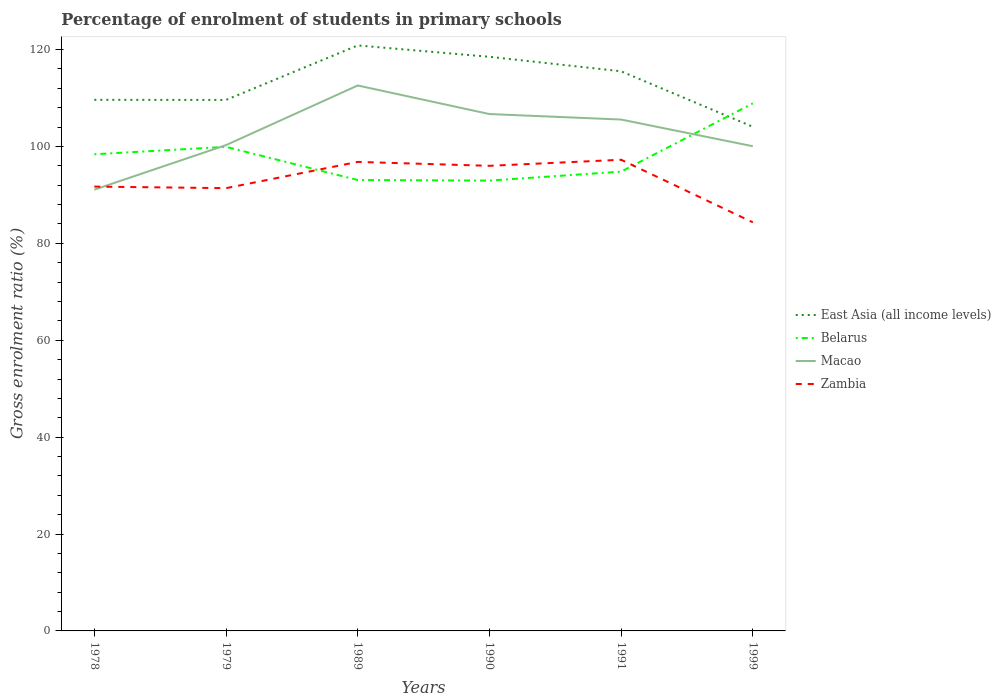Across all years, what is the maximum percentage of students enrolled in primary schools in East Asia (all income levels)?
Your response must be concise. 104.06. What is the total percentage of students enrolled in primary schools in Macao in the graph?
Your answer should be compact. -6.41. What is the difference between the highest and the second highest percentage of students enrolled in primary schools in Macao?
Ensure brevity in your answer.  21.51. How many lines are there?
Provide a succinct answer. 4. How many years are there in the graph?
Make the answer very short. 6. What is the difference between two consecutive major ticks on the Y-axis?
Your response must be concise. 20. Are the values on the major ticks of Y-axis written in scientific E-notation?
Keep it short and to the point. No. Where does the legend appear in the graph?
Give a very brief answer. Center right. How are the legend labels stacked?
Your answer should be compact. Vertical. What is the title of the graph?
Give a very brief answer. Percentage of enrolment of students in primary schools. Does "Pacific island small states" appear as one of the legend labels in the graph?
Your response must be concise. No. What is the label or title of the Y-axis?
Provide a short and direct response. Gross enrolment ratio (%). What is the Gross enrolment ratio (%) of East Asia (all income levels) in 1978?
Offer a very short reply. 109.63. What is the Gross enrolment ratio (%) in Belarus in 1978?
Your response must be concise. 98.39. What is the Gross enrolment ratio (%) in Macao in 1978?
Make the answer very short. 91.08. What is the Gross enrolment ratio (%) of Zambia in 1978?
Keep it short and to the point. 91.71. What is the Gross enrolment ratio (%) in East Asia (all income levels) in 1979?
Make the answer very short. 109.6. What is the Gross enrolment ratio (%) in Belarus in 1979?
Offer a very short reply. 99.92. What is the Gross enrolment ratio (%) of Macao in 1979?
Ensure brevity in your answer.  100.28. What is the Gross enrolment ratio (%) of Zambia in 1979?
Offer a terse response. 91.39. What is the Gross enrolment ratio (%) of East Asia (all income levels) in 1989?
Give a very brief answer. 120.86. What is the Gross enrolment ratio (%) of Belarus in 1989?
Give a very brief answer. 93.07. What is the Gross enrolment ratio (%) in Macao in 1989?
Make the answer very short. 112.59. What is the Gross enrolment ratio (%) of Zambia in 1989?
Provide a succinct answer. 96.81. What is the Gross enrolment ratio (%) of East Asia (all income levels) in 1990?
Your response must be concise. 118.51. What is the Gross enrolment ratio (%) in Belarus in 1990?
Make the answer very short. 92.96. What is the Gross enrolment ratio (%) in Macao in 1990?
Offer a very short reply. 106.69. What is the Gross enrolment ratio (%) of Zambia in 1990?
Give a very brief answer. 96. What is the Gross enrolment ratio (%) of East Asia (all income levels) in 1991?
Your answer should be compact. 115.52. What is the Gross enrolment ratio (%) in Belarus in 1991?
Your response must be concise. 94.8. What is the Gross enrolment ratio (%) of Macao in 1991?
Your answer should be very brief. 105.55. What is the Gross enrolment ratio (%) in Zambia in 1991?
Provide a short and direct response. 97.25. What is the Gross enrolment ratio (%) in East Asia (all income levels) in 1999?
Keep it short and to the point. 104.06. What is the Gross enrolment ratio (%) of Belarus in 1999?
Ensure brevity in your answer.  108.89. What is the Gross enrolment ratio (%) in Macao in 1999?
Provide a short and direct response. 100.05. What is the Gross enrolment ratio (%) in Zambia in 1999?
Your answer should be very brief. 84.34. Across all years, what is the maximum Gross enrolment ratio (%) of East Asia (all income levels)?
Your answer should be very brief. 120.86. Across all years, what is the maximum Gross enrolment ratio (%) in Belarus?
Provide a short and direct response. 108.89. Across all years, what is the maximum Gross enrolment ratio (%) of Macao?
Provide a short and direct response. 112.59. Across all years, what is the maximum Gross enrolment ratio (%) in Zambia?
Provide a short and direct response. 97.25. Across all years, what is the minimum Gross enrolment ratio (%) of East Asia (all income levels)?
Provide a short and direct response. 104.06. Across all years, what is the minimum Gross enrolment ratio (%) of Belarus?
Give a very brief answer. 92.96. Across all years, what is the minimum Gross enrolment ratio (%) in Macao?
Ensure brevity in your answer.  91.08. Across all years, what is the minimum Gross enrolment ratio (%) of Zambia?
Provide a short and direct response. 84.34. What is the total Gross enrolment ratio (%) in East Asia (all income levels) in the graph?
Offer a terse response. 678.17. What is the total Gross enrolment ratio (%) of Belarus in the graph?
Make the answer very short. 588.03. What is the total Gross enrolment ratio (%) of Macao in the graph?
Your answer should be compact. 616.23. What is the total Gross enrolment ratio (%) in Zambia in the graph?
Your response must be concise. 557.51. What is the difference between the Gross enrolment ratio (%) of East Asia (all income levels) in 1978 and that in 1979?
Offer a terse response. 0.02. What is the difference between the Gross enrolment ratio (%) of Belarus in 1978 and that in 1979?
Your answer should be very brief. -1.54. What is the difference between the Gross enrolment ratio (%) in Macao in 1978 and that in 1979?
Offer a terse response. -9.2. What is the difference between the Gross enrolment ratio (%) in Zambia in 1978 and that in 1979?
Ensure brevity in your answer.  0.32. What is the difference between the Gross enrolment ratio (%) in East Asia (all income levels) in 1978 and that in 1989?
Offer a very short reply. -11.23. What is the difference between the Gross enrolment ratio (%) in Belarus in 1978 and that in 1989?
Provide a short and direct response. 5.32. What is the difference between the Gross enrolment ratio (%) of Macao in 1978 and that in 1989?
Make the answer very short. -21.51. What is the difference between the Gross enrolment ratio (%) of Zambia in 1978 and that in 1989?
Offer a terse response. -5.1. What is the difference between the Gross enrolment ratio (%) in East Asia (all income levels) in 1978 and that in 1990?
Ensure brevity in your answer.  -8.88. What is the difference between the Gross enrolment ratio (%) in Belarus in 1978 and that in 1990?
Make the answer very short. 5.43. What is the difference between the Gross enrolment ratio (%) of Macao in 1978 and that in 1990?
Your response must be concise. -15.61. What is the difference between the Gross enrolment ratio (%) in Zambia in 1978 and that in 1990?
Give a very brief answer. -4.29. What is the difference between the Gross enrolment ratio (%) of East Asia (all income levels) in 1978 and that in 1991?
Your answer should be very brief. -5.89. What is the difference between the Gross enrolment ratio (%) of Belarus in 1978 and that in 1991?
Offer a very short reply. 3.58. What is the difference between the Gross enrolment ratio (%) of Macao in 1978 and that in 1991?
Keep it short and to the point. -14.48. What is the difference between the Gross enrolment ratio (%) of Zambia in 1978 and that in 1991?
Your answer should be compact. -5.54. What is the difference between the Gross enrolment ratio (%) in East Asia (all income levels) in 1978 and that in 1999?
Ensure brevity in your answer.  5.57. What is the difference between the Gross enrolment ratio (%) in Belarus in 1978 and that in 1999?
Your response must be concise. -10.5. What is the difference between the Gross enrolment ratio (%) in Macao in 1978 and that in 1999?
Your answer should be compact. -8.97. What is the difference between the Gross enrolment ratio (%) in Zambia in 1978 and that in 1999?
Provide a short and direct response. 7.38. What is the difference between the Gross enrolment ratio (%) in East Asia (all income levels) in 1979 and that in 1989?
Your answer should be very brief. -11.25. What is the difference between the Gross enrolment ratio (%) in Belarus in 1979 and that in 1989?
Keep it short and to the point. 6.85. What is the difference between the Gross enrolment ratio (%) in Macao in 1979 and that in 1989?
Your response must be concise. -12.31. What is the difference between the Gross enrolment ratio (%) in Zambia in 1979 and that in 1989?
Provide a short and direct response. -5.42. What is the difference between the Gross enrolment ratio (%) in East Asia (all income levels) in 1979 and that in 1990?
Give a very brief answer. -8.9. What is the difference between the Gross enrolment ratio (%) in Belarus in 1979 and that in 1990?
Provide a succinct answer. 6.97. What is the difference between the Gross enrolment ratio (%) of Macao in 1979 and that in 1990?
Offer a terse response. -6.41. What is the difference between the Gross enrolment ratio (%) of Zambia in 1979 and that in 1990?
Provide a succinct answer. -4.61. What is the difference between the Gross enrolment ratio (%) of East Asia (all income levels) in 1979 and that in 1991?
Offer a terse response. -5.91. What is the difference between the Gross enrolment ratio (%) in Belarus in 1979 and that in 1991?
Give a very brief answer. 5.12. What is the difference between the Gross enrolment ratio (%) in Macao in 1979 and that in 1991?
Your answer should be very brief. -5.28. What is the difference between the Gross enrolment ratio (%) in Zambia in 1979 and that in 1991?
Your answer should be compact. -5.86. What is the difference between the Gross enrolment ratio (%) of East Asia (all income levels) in 1979 and that in 1999?
Ensure brevity in your answer.  5.54. What is the difference between the Gross enrolment ratio (%) in Belarus in 1979 and that in 1999?
Ensure brevity in your answer.  -8.97. What is the difference between the Gross enrolment ratio (%) of Macao in 1979 and that in 1999?
Make the answer very short. 0.23. What is the difference between the Gross enrolment ratio (%) of Zambia in 1979 and that in 1999?
Your answer should be very brief. 7.05. What is the difference between the Gross enrolment ratio (%) of East Asia (all income levels) in 1989 and that in 1990?
Make the answer very short. 2.35. What is the difference between the Gross enrolment ratio (%) in Belarus in 1989 and that in 1990?
Ensure brevity in your answer.  0.12. What is the difference between the Gross enrolment ratio (%) of Macao in 1989 and that in 1990?
Offer a terse response. 5.9. What is the difference between the Gross enrolment ratio (%) in Zambia in 1989 and that in 1990?
Provide a short and direct response. 0.81. What is the difference between the Gross enrolment ratio (%) of East Asia (all income levels) in 1989 and that in 1991?
Offer a very short reply. 5.34. What is the difference between the Gross enrolment ratio (%) in Belarus in 1989 and that in 1991?
Make the answer very short. -1.73. What is the difference between the Gross enrolment ratio (%) in Macao in 1989 and that in 1991?
Offer a very short reply. 7.03. What is the difference between the Gross enrolment ratio (%) of Zambia in 1989 and that in 1991?
Keep it short and to the point. -0.44. What is the difference between the Gross enrolment ratio (%) of East Asia (all income levels) in 1989 and that in 1999?
Keep it short and to the point. 16.8. What is the difference between the Gross enrolment ratio (%) of Belarus in 1989 and that in 1999?
Provide a succinct answer. -15.82. What is the difference between the Gross enrolment ratio (%) in Macao in 1989 and that in 1999?
Your answer should be very brief. 12.54. What is the difference between the Gross enrolment ratio (%) of Zambia in 1989 and that in 1999?
Provide a succinct answer. 12.48. What is the difference between the Gross enrolment ratio (%) in East Asia (all income levels) in 1990 and that in 1991?
Keep it short and to the point. 2.99. What is the difference between the Gross enrolment ratio (%) in Belarus in 1990 and that in 1991?
Your answer should be very brief. -1.85. What is the difference between the Gross enrolment ratio (%) of Macao in 1990 and that in 1991?
Your answer should be compact. 1.14. What is the difference between the Gross enrolment ratio (%) in Zambia in 1990 and that in 1991?
Your answer should be compact. -1.25. What is the difference between the Gross enrolment ratio (%) in East Asia (all income levels) in 1990 and that in 1999?
Provide a short and direct response. 14.45. What is the difference between the Gross enrolment ratio (%) of Belarus in 1990 and that in 1999?
Provide a short and direct response. -15.94. What is the difference between the Gross enrolment ratio (%) of Macao in 1990 and that in 1999?
Your response must be concise. 6.64. What is the difference between the Gross enrolment ratio (%) in Zambia in 1990 and that in 1999?
Your answer should be very brief. 11.67. What is the difference between the Gross enrolment ratio (%) in East Asia (all income levels) in 1991 and that in 1999?
Your response must be concise. 11.46. What is the difference between the Gross enrolment ratio (%) of Belarus in 1991 and that in 1999?
Make the answer very short. -14.09. What is the difference between the Gross enrolment ratio (%) in Macao in 1991 and that in 1999?
Keep it short and to the point. 5.51. What is the difference between the Gross enrolment ratio (%) of Zambia in 1991 and that in 1999?
Keep it short and to the point. 12.92. What is the difference between the Gross enrolment ratio (%) of East Asia (all income levels) in 1978 and the Gross enrolment ratio (%) of Belarus in 1979?
Keep it short and to the point. 9.7. What is the difference between the Gross enrolment ratio (%) in East Asia (all income levels) in 1978 and the Gross enrolment ratio (%) in Macao in 1979?
Your answer should be very brief. 9.35. What is the difference between the Gross enrolment ratio (%) in East Asia (all income levels) in 1978 and the Gross enrolment ratio (%) in Zambia in 1979?
Your answer should be compact. 18.24. What is the difference between the Gross enrolment ratio (%) of Belarus in 1978 and the Gross enrolment ratio (%) of Macao in 1979?
Offer a very short reply. -1.89. What is the difference between the Gross enrolment ratio (%) of Belarus in 1978 and the Gross enrolment ratio (%) of Zambia in 1979?
Give a very brief answer. 6.99. What is the difference between the Gross enrolment ratio (%) of Macao in 1978 and the Gross enrolment ratio (%) of Zambia in 1979?
Give a very brief answer. -0.31. What is the difference between the Gross enrolment ratio (%) in East Asia (all income levels) in 1978 and the Gross enrolment ratio (%) in Belarus in 1989?
Provide a short and direct response. 16.56. What is the difference between the Gross enrolment ratio (%) of East Asia (all income levels) in 1978 and the Gross enrolment ratio (%) of Macao in 1989?
Make the answer very short. -2.96. What is the difference between the Gross enrolment ratio (%) in East Asia (all income levels) in 1978 and the Gross enrolment ratio (%) in Zambia in 1989?
Provide a succinct answer. 12.81. What is the difference between the Gross enrolment ratio (%) of Belarus in 1978 and the Gross enrolment ratio (%) of Macao in 1989?
Keep it short and to the point. -14.2. What is the difference between the Gross enrolment ratio (%) of Belarus in 1978 and the Gross enrolment ratio (%) of Zambia in 1989?
Provide a short and direct response. 1.57. What is the difference between the Gross enrolment ratio (%) of Macao in 1978 and the Gross enrolment ratio (%) of Zambia in 1989?
Keep it short and to the point. -5.74. What is the difference between the Gross enrolment ratio (%) in East Asia (all income levels) in 1978 and the Gross enrolment ratio (%) in Belarus in 1990?
Provide a succinct answer. 16.67. What is the difference between the Gross enrolment ratio (%) in East Asia (all income levels) in 1978 and the Gross enrolment ratio (%) in Macao in 1990?
Keep it short and to the point. 2.94. What is the difference between the Gross enrolment ratio (%) of East Asia (all income levels) in 1978 and the Gross enrolment ratio (%) of Zambia in 1990?
Keep it short and to the point. 13.62. What is the difference between the Gross enrolment ratio (%) of Belarus in 1978 and the Gross enrolment ratio (%) of Macao in 1990?
Provide a succinct answer. -8.3. What is the difference between the Gross enrolment ratio (%) in Belarus in 1978 and the Gross enrolment ratio (%) in Zambia in 1990?
Provide a short and direct response. 2.38. What is the difference between the Gross enrolment ratio (%) in Macao in 1978 and the Gross enrolment ratio (%) in Zambia in 1990?
Give a very brief answer. -4.93. What is the difference between the Gross enrolment ratio (%) in East Asia (all income levels) in 1978 and the Gross enrolment ratio (%) in Belarus in 1991?
Provide a succinct answer. 14.83. What is the difference between the Gross enrolment ratio (%) of East Asia (all income levels) in 1978 and the Gross enrolment ratio (%) of Macao in 1991?
Ensure brevity in your answer.  4.07. What is the difference between the Gross enrolment ratio (%) of East Asia (all income levels) in 1978 and the Gross enrolment ratio (%) of Zambia in 1991?
Your response must be concise. 12.37. What is the difference between the Gross enrolment ratio (%) in Belarus in 1978 and the Gross enrolment ratio (%) in Macao in 1991?
Offer a terse response. -7.17. What is the difference between the Gross enrolment ratio (%) of Belarus in 1978 and the Gross enrolment ratio (%) of Zambia in 1991?
Give a very brief answer. 1.13. What is the difference between the Gross enrolment ratio (%) of Macao in 1978 and the Gross enrolment ratio (%) of Zambia in 1991?
Provide a short and direct response. -6.18. What is the difference between the Gross enrolment ratio (%) of East Asia (all income levels) in 1978 and the Gross enrolment ratio (%) of Belarus in 1999?
Provide a succinct answer. 0.74. What is the difference between the Gross enrolment ratio (%) of East Asia (all income levels) in 1978 and the Gross enrolment ratio (%) of Macao in 1999?
Offer a terse response. 9.58. What is the difference between the Gross enrolment ratio (%) in East Asia (all income levels) in 1978 and the Gross enrolment ratio (%) in Zambia in 1999?
Provide a succinct answer. 25.29. What is the difference between the Gross enrolment ratio (%) of Belarus in 1978 and the Gross enrolment ratio (%) of Macao in 1999?
Your answer should be very brief. -1.66. What is the difference between the Gross enrolment ratio (%) of Belarus in 1978 and the Gross enrolment ratio (%) of Zambia in 1999?
Your response must be concise. 14.05. What is the difference between the Gross enrolment ratio (%) of Macao in 1978 and the Gross enrolment ratio (%) of Zambia in 1999?
Keep it short and to the point. 6.74. What is the difference between the Gross enrolment ratio (%) in East Asia (all income levels) in 1979 and the Gross enrolment ratio (%) in Belarus in 1989?
Provide a succinct answer. 16.53. What is the difference between the Gross enrolment ratio (%) of East Asia (all income levels) in 1979 and the Gross enrolment ratio (%) of Macao in 1989?
Provide a succinct answer. -2.98. What is the difference between the Gross enrolment ratio (%) in East Asia (all income levels) in 1979 and the Gross enrolment ratio (%) in Zambia in 1989?
Ensure brevity in your answer.  12.79. What is the difference between the Gross enrolment ratio (%) in Belarus in 1979 and the Gross enrolment ratio (%) in Macao in 1989?
Give a very brief answer. -12.66. What is the difference between the Gross enrolment ratio (%) in Belarus in 1979 and the Gross enrolment ratio (%) in Zambia in 1989?
Provide a succinct answer. 3.11. What is the difference between the Gross enrolment ratio (%) in Macao in 1979 and the Gross enrolment ratio (%) in Zambia in 1989?
Give a very brief answer. 3.46. What is the difference between the Gross enrolment ratio (%) in East Asia (all income levels) in 1979 and the Gross enrolment ratio (%) in Belarus in 1990?
Keep it short and to the point. 16.65. What is the difference between the Gross enrolment ratio (%) of East Asia (all income levels) in 1979 and the Gross enrolment ratio (%) of Macao in 1990?
Offer a very short reply. 2.91. What is the difference between the Gross enrolment ratio (%) in East Asia (all income levels) in 1979 and the Gross enrolment ratio (%) in Zambia in 1990?
Provide a succinct answer. 13.6. What is the difference between the Gross enrolment ratio (%) of Belarus in 1979 and the Gross enrolment ratio (%) of Macao in 1990?
Your response must be concise. -6.77. What is the difference between the Gross enrolment ratio (%) in Belarus in 1979 and the Gross enrolment ratio (%) in Zambia in 1990?
Provide a succinct answer. 3.92. What is the difference between the Gross enrolment ratio (%) of Macao in 1979 and the Gross enrolment ratio (%) of Zambia in 1990?
Make the answer very short. 4.27. What is the difference between the Gross enrolment ratio (%) in East Asia (all income levels) in 1979 and the Gross enrolment ratio (%) in Belarus in 1991?
Offer a very short reply. 14.8. What is the difference between the Gross enrolment ratio (%) of East Asia (all income levels) in 1979 and the Gross enrolment ratio (%) of Macao in 1991?
Your response must be concise. 4.05. What is the difference between the Gross enrolment ratio (%) in East Asia (all income levels) in 1979 and the Gross enrolment ratio (%) in Zambia in 1991?
Keep it short and to the point. 12.35. What is the difference between the Gross enrolment ratio (%) in Belarus in 1979 and the Gross enrolment ratio (%) in Macao in 1991?
Your answer should be compact. -5.63. What is the difference between the Gross enrolment ratio (%) of Belarus in 1979 and the Gross enrolment ratio (%) of Zambia in 1991?
Give a very brief answer. 2.67. What is the difference between the Gross enrolment ratio (%) in Macao in 1979 and the Gross enrolment ratio (%) in Zambia in 1991?
Provide a succinct answer. 3.02. What is the difference between the Gross enrolment ratio (%) in East Asia (all income levels) in 1979 and the Gross enrolment ratio (%) in Belarus in 1999?
Your answer should be compact. 0.71. What is the difference between the Gross enrolment ratio (%) in East Asia (all income levels) in 1979 and the Gross enrolment ratio (%) in Macao in 1999?
Provide a short and direct response. 9.56. What is the difference between the Gross enrolment ratio (%) in East Asia (all income levels) in 1979 and the Gross enrolment ratio (%) in Zambia in 1999?
Provide a succinct answer. 25.27. What is the difference between the Gross enrolment ratio (%) of Belarus in 1979 and the Gross enrolment ratio (%) of Macao in 1999?
Ensure brevity in your answer.  -0.12. What is the difference between the Gross enrolment ratio (%) in Belarus in 1979 and the Gross enrolment ratio (%) in Zambia in 1999?
Offer a very short reply. 15.58. What is the difference between the Gross enrolment ratio (%) of Macao in 1979 and the Gross enrolment ratio (%) of Zambia in 1999?
Provide a succinct answer. 15.94. What is the difference between the Gross enrolment ratio (%) in East Asia (all income levels) in 1989 and the Gross enrolment ratio (%) in Belarus in 1990?
Keep it short and to the point. 27.9. What is the difference between the Gross enrolment ratio (%) in East Asia (all income levels) in 1989 and the Gross enrolment ratio (%) in Macao in 1990?
Your answer should be compact. 14.17. What is the difference between the Gross enrolment ratio (%) in East Asia (all income levels) in 1989 and the Gross enrolment ratio (%) in Zambia in 1990?
Make the answer very short. 24.85. What is the difference between the Gross enrolment ratio (%) in Belarus in 1989 and the Gross enrolment ratio (%) in Macao in 1990?
Ensure brevity in your answer.  -13.62. What is the difference between the Gross enrolment ratio (%) of Belarus in 1989 and the Gross enrolment ratio (%) of Zambia in 1990?
Your answer should be compact. -2.93. What is the difference between the Gross enrolment ratio (%) of Macao in 1989 and the Gross enrolment ratio (%) of Zambia in 1990?
Your response must be concise. 16.58. What is the difference between the Gross enrolment ratio (%) in East Asia (all income levels) in 1989 and the Gross enrolment ratio (%) in Belarus in 1991?
Your answer should be very brief. 26.05. What is the difference between the Gross enrolment ratio (%) in East Asia (all income levels) in 1989 and the Gross enrolment ratio (%) in Macao in 1991?
Give a very brief answer. 15.3. What is the difference between the Gross enrolment ratio (%) in East Asia (all income levels) in 1989 and the Gross enrolment ratio (%) in Zambia in 1991?
Your answer should be compact. 23.6. What is the difference between the Gross enrolment ratio (%) of Belarus in 1989 and the Gross enrolment ratio (%) of Macao in 1991?
Provide a succinct answer. -12.48. What is the difference between the Gross enrolment ratio (%) of Belarus in 1989 and the Gross enrolment ratio (%) of Zambia in 1991?
Offer a terse response. -4.18. What is the difference between the Gross enrolment ratio (%) of Macao in 1989 and the Gross enrolment ratio (%) of Zambia in 1991?
Offer a very short reply. 15.33. What is the difference between the Gross enrolment ratio (%) of East Asia (all income levels) in 1989 and the Gross enrolment ratio (%) of Belarus in 1999?
Keep it short and to the point. 11.97. What is the difference between the Gross enrolment ratio (%) of East Asia (all income levels) in 1989 and the Gross enrolment ratio (%) of Macao in 1999?
Your answer should be compact. 20.81. What is the difference between the Gross enrolment ratio (%) in East Asia (all income levels) in 1989 and the Gross enrolment ratio (%) in Zambia in 1999?
Keep it short and to the point. 36.52. What is the difference between the Gross enrolment ratio (%) in Belarus in 1989 and the Gross enrolment ratio (%) in Macao in 1999?
Your response must be concise. -6.98. What is the difference between the Gross enrolment ratio (%) of Belarus in 1989 and the Gross enrolment ratio (%) of Zambia in 1999?
Keep it short and to the point. 8.73. What is the difference between the Gross enrolment ratio (%) in Macao in 1989 and the Gross enrolment ratio (%) in Zambia in 1999?
Provide a succinct answer. 28.25. What is the difference between the Gross enrolment ratio (%) of East Asia (all income levels) in 1990 and the Gross enrolment ratio (%) of Belarus in 1991?
Your answer should be very brief. 23.71. What is the difference between the Gross enrolment ratio (%) of East Asia (all income levels) in 1990 and the Gross enrolment ratio (%) of Macao in 1991?
Provide a short and direct response. 12.95. What is the difference between the Gross enrolment ratio (%) of East Asia (all income levels) in 1990 and the Gross enrolment ratio (%) of Zambia in 1991?
Your answer should be very brief. 21.25. What is the difference between the Gross enrolment ratio (%) in Belarus in 1990 and the Gross enrolment ratio (%) in Macao in 1991?
Your answer should be very brief. -12.6. What is the difference between the Gross enrolment ratio (%) of Belarus in 1990 and the Gross enrolment ratio (%) of Zambia in 1991?
Your response must be concise. -4.3. What is the difference between the Gross enrolment ratio (%) in Macao in 1990 and the Gross enrolment ratio (%) in Zambia in 1991?
Provide a succinct answer. 9.44. What is the difference between the Gross enrolment ratio (%) in East Asia (all income levels) in 1990 and the Gross enrolment ratio (%) in Belarus in 1999?
Provide a short and direct response. 9.62. What is the difference between the Gross enrolment ratio (%) in East Asia (all income levels) in 1990 and the Gross enrolment ratio (%) in Macao in 1999?
Provide a succinct answer. 18.46. What is the difference between the Gross enrolment ratio (%) of East Asia (all income levels) in 1990 and the Gross enrolment ratio (%) of Zambia in 1999?
Your answer should be very brief. 34.17. What is the difference between the Gross enrolment ratio (%) of Belarus in 1990 and the Gross enrolment ratio (%) of Macao in 1999?
Your answer should be very brief. -7.09. What is the difference between the Gross enrolment ratio (%) of Belarus in 1990 and the Gross enrolment ratio (%) of Zambia in 1999?
Ensure brevity in your answer.  8.62. What is the difference between the Gross enrolment ratio (%) in Macao in 1990 and the Gross enrolment ratio (%) in Zambia in 1999?
Your response must be concise. 22.35. What is the difference between the Gross enrolment ratio (%) of East Asia (all income levels) in 1991 and the Gross enrolment ratio (%) of Belarus in 1999?
Your response must be concise. 6.63. What is the difference between the Gross enrolment ratio (%) of East Asia (all income levels) in 1991 and the Gross enrolment ratio (%) of Macao in 1999?
Offer a terse response. 15.47. What is the difference between the Gross enrolment ratio (%) in East Asia (all income levels) in 1991 and the Gross enrolment ratio (%) in Zambia in 1999?
Provide a short and direct response. 31.18. What is the difference between the Gross enrolment ratio (%) in Belarus in 1991 and the Gross enrolment ratio (%) in Macao in 1999?
Make the answer very short. -5.25. What is the difference between the Gross enrolment ratio (%) of Belarus in 1991 and the Gross enrolment ratio (%) of Zambia in 1999?
Provide a succinct answer. 10.46. What is the difference between the Gross enrolment ratio (%) of Macao in 1991 and the Gross enrolment ratio (%) of Zambia in 1999?
Give a very brief answer. 21.22. What is the average Gross enrolment ratio (%) in East Asia (all income levels) per year?
Your response must be concise. 113.03. What is the average Gross enrolment ratio (%) of Belarus per year?
Give a very brief answer. 98. What is the average Gross enrolment ratio (%) of Macao per year?
Offer a very short reply. 102.71. What is the average Gross enrolment ratio (%) in Zambia per year?
Your response must be concise. 92.92. In the year 1978, what is the difference between the Gross enrolment ratio (%) in East Asia (all income levels) and Gross enrolment ratio (%) in Belarus?
Offer a very short reply. 11.24. In the year 1978, what is the difference between the Gross enrolment ratio (%) of East Asia (all income levels) and Gross enrolment ratio (%) of Macao?
Offer a very short reply. 18.55. In the year 1978, what is the difference between the Gross enrolment ratio (%) in East Asia (all income levels) and Gross enrolment ratio (%) in Zambia?
Your answer should be compact. 17.91. In the year 1978, what is the difference between the Gross enrolment ratio (%) in Belarus and Gross enrolment ratio (%) in Macao?
Your answer should be compact. 7.31. In the year 1978, what is the difference between the Gross enrolment ratio (%) in Belarus and Gross enrolment ratio (%) in Zambia?
Give a very brief answer. 6.67. In the year 1978, what is the difference between the Gross enrolment ratio (%) in Macao and Gross enrolment ratio (%) in Zambia?
Provide a succinct answer. -0.64. In the year 1979, what is the difference between the Gross enrolment ratio (%) of East Asia (all income levels) and Gross enrolment ratio (%) of Belarus?
Offer a very short reply. 9.68. In the year 1979, what is the difference between the Gross enrolment ratio (%) in East Asia (all income levels) and Gross enrolment ratio (%) in Macao?
Offer a terse response. 9.32. In the year 1979, what is the difference between the Gross enrolment ratio (%) in East Asia (all income levels) and Gross enrolment ratio (%) in Zambia?
Ensure brevity in your answer.  18.21. In the year 1979, what is the difference between the Gross enrolment ratio (%) in Belarus and Gross enrolment ratio (%) in Macao?
Give a very brief answer. -0.36. In the year 1979, what is the difference between the Gross enrolment ratio (%) of Belarus and Gross enrolment ratio (%) of Zambia?
Keep it short and to the point. 8.53. In the year 1979, what is the difference between the Gross enrolment ratio (%) of Macao and Gross enrolment ratio (%) of Zambia?
Ensure brevity in your answer.  8.89. In the year 1989, what is the difference between the Gross enrolment ratio (%) of East Asia (all income levels) and Gross enrolment ratio (%) of Belarus?
Your response must be concise. 27.79. In the year 1989, what is the difference between the Gross enrolment ratio (%) in East Asia (all income levels) and Gross enrolment ratio (%) in Macao?
Give a very brief answer. 8.27. In the year 1989, what is the difference between the Gross enrolment ratio (%) in East Asia (all income levels) and Gross enrolment ratio (%) in Zambia?
Ensure brevity in your answer.  24.04. In the year 1989, what is the difference between the Gross enrolment ratio (%) of Belarus and Gross enrolment ratio (%) of Macao?
Keep it short and to the point. -19.52. In the year 1989, what is the difference between the Gross enrolment ratio (%) of Belarus and Gross enrolment ratio (%) of Zambia?
Keep it short and to the point. -3.74. In the year 1989, what is the difference between the Gross enrolment ratio (%) in Macao and Gross enrolment ratio (%) in Zambia?
Make the answer very short. 15.77. In the year 1990, what is the difference between the Gross enrolment ratio (%) in East Asia (all income levels) and Gross enrolment ratio (%) in Belarus?
Give a very brief answer. 25.55. In the year 1990, what is the difference between the Gross enrolment ratio (%) in East Asia (all income levels) and Gross enrolment ratio (%) in Macao?
Provide a succinct answer. 11.82. In the year 1990, what is the difference between the Gross enrolment ratio (%) in East Asia (all income levels) and Gross enrolment ratio (%) in Zambia?
Give a very brief answer. 22.5. In the year 1990, what is the difference between the Gross enrolment ratio (%) in Belarus and Gross enrolment ratio (%) in Macao?
Offer a terse response. -13.73. In the year 1990, what is the difference between the Gross enrolment ratio (%) in Belarus and Gross enrolment ratio (%) in Zambia?
Keep it short and to the point. -3.05. In the year 1990, what is the difference between the Gross enrolment ratio (%) in Macao and Gross enrolment ratio (%) in Zambia?
Keep it short and to the point. 10.69. In the year 1991, what is the difference between the Gross enrolment ratio (%) of East Asia (all income levels) and Gross enrolment ratio (%) of Belarus?
Keep it short and to the point. 20.71. In the year 1991, what is the difference between the Gross enrolment ratio (%) of East Asia (all income levels) and Gross enrolment ratio (%) of Macao?
Your response must be concise. 9.96. In the year 1991, what is the difference between the Gross enrolment ratio (%) in East Asia (all income levels) and Gross enrolment ratio (%) in Zambia?
Your response must be concise. 18.26. In the year 1991, what is the difference between the Gross enrolment ratio (%) of Belarus and Gross enrolment ratio (%) of Macao?
Give a very brief answer. -10.75. In the year 1991, what is the difference between the Gross enrolment ratio (%) of Belarus and Gross enrolment ratio (%) of Zambia?
Make the answer very short. -2.45. In the year 1991, what is the difference between the Gross enrolment ratio (%) of Macao and Gross enrolment ratio (%) of Zambia?
Offer a terse response. 8.3. In the year 1999, what is the difference between the Gross enrolment ratio (%) of East Asia (all income levels) and Gross enrolment ratio (%) of Belarus?
Keep it short and to the point. -4.83. In the year 1999, what is the difference between the Gross enrolment ratio (%) in East Asia (all income levels) and Gross enrolment ratio (%) in Macao?
Your answer should be compact. 4.01. In the year 1999, what is the difference between the Gross enrolment ratio (%) of East Asia (all income levels) and Gross enrolment ratio (%) of Zambia?
Keep it short and to the point. 19.72. In the year 1999, what is the difference between the Gross enrolment ratio (%) of Belarus and Gross enrolment ratio (%) of Macao?
Provide a short and direct response. 8.84. In the year 1999, what is the difference between the Gross enrolment ratio (%) of Belarus and Gross enrolment ratio (%) of Zambia?
Offer a very short reply. 24.55. In the year 1999, what is the difference between the Gross enrolment ratio (%) of Macao and Gross enrolment ratio (%) of Zambia?
Offer a very short reply. 15.71. What is the ratio of the Gross enrolment ratio (%) of Belarus in 1978 to that in 1979?
Give a very brief answer. 0.98. What is the ratio of the Gross enrolment ratio (%) in Macao in 1978 to that in 1979?
Give a very brief answer. 0.91. What is the ratio of the Gross enrolment ratio (%) in East Asia (all income levels) in 1978 to that in 1989?
Provide a succinct answer. 0.91. What is the ratio of the Gross enrolment ratio (%) of Belarus in 1978 to that in 1989?
Make the answer very short. 1.06. What is the ratio of the Gross enrolment ratio (%) of Macao in 1978 to that in 1989?
Your answer should be compact. 0.81. What is the ratio of the Gross enrolment ratio (%) in Zambia in 1978 to that in 1989?
Offer a very short reply. 0.95. What is the ratio of the Gross enrolment ratio (%) of East Asia (all income levels) in 1978 to that in 1990?
Provide a succinct answer. 0.93. What is the ratio of the Gross enrolment ratio (%) in Belarus in 1978 to that in 1990?
Give a very brief answer. 1.06. What is the ratio of the Gross enrolment ratio (%) of Macao in 1978 to that in 1990?
Ensure brevity in your answer.  0.85. What is the ratio of the Gross enrolment ratio (%) of Zambia in 1978 to that in 1990?
Offer a terse response. 0.96. What is the ratio of the Gross enrolment ratio (%) of East Asia (all income levels) in 1978 to that in 1991?
Make the answer very short. 0.95. What is the ratio of the Gross enrolment ratio (%) of Belarus in 1978 to that in 1991?
Ensure brevity in your answer.  1.04. What is the ratio of the Gross enrolment ratio (%) in Macao in 1978 to that in 1991?
Provide a succinct answer. 0.86. What is the ratio of the Gross enrolment ratio (%) in Zambia in 1978 to that in 1991?
Keep it short and to the point. 0.94. What is the ratio of the Gross enrolment ratio (%) in East Asia (all income levels) in 1978 to that in 1999?
Make the answer very short. 1.05. What is the ratio of the Gross enrolment ratio (%) in Belarus in 1978 to that in 1999?
Keep it short and to the point. 0.9. What is the ratio of the Gross enrolment ratio (%) in Macao in 1978 to that in 1999?
Your answer should be very brief. 0.91. What is the ratio of the Gross enrolment ratio (%) in Zambia in 1978 to that in 1999?
Your response must be concise. 1.09. What is the ratio of the Gross enrolment ratio (%) of East Asia (all income levels) in 1979 to that in 1989?
Your answer should be compact. 0.91. What is the ratio of the Gross enrolment ratio (%) of Belarus in 1979 to that in 1989?
Your response must be concise. 1.07. What is the ratio of the Gross enrolment ratio (%) of Macao in 1979 to that in 1989?
Ensure brevity in your answer.  0.89. What is the ratio of the Gross enrolment ratio (%) in Zambia in 1979 to that in 1989?
Provide a short and direct response. 0.94. What is the ratio of the Gross enrolment ratio (%) in East Asia (all income levels) in 1979 to that in 1990?
Offer a very short reply. 0.92. What is the ratio of the Gross enrolment ratio (%) in Belarus in 1979 to that in 1990?
Provide a short and direct response. 1.07. What is the ratio of the Gross enrolment ratio (%) in Macao in 1979 to that in 1990?
Provide a succinct answer. 0.94. What is the ratio of the Gross enrolment ratio (%) in Zambia in 1979 to that in 1990?
Keep it short and to the point. 0.95. What is the ratio of the Gross enrolment ratio (%) in East Asia (all income levels) in 1979 to that in 1991?
Provide a succinct answer. 0.95. What is the ratio of the Gross enrolment ratio (%) in Belarus in 1979 to that in 1991?
Ensure brevity in your answer.  1.05. What is the ratio of the Gross enrolment ratio (%) of Zambia in 1979 to that in 1991?
Offer a terse response. 0.94. What is the ratio of the Gross enrolment ratio (%) of East Asia (all income levels) in 1979 to that in 1999?
Give a very brief answer. 1.05. What is the ratio of the Gross enrolment ratio (%) of Belarus in 1979 to that in 1999?
Offer a very short reply. 0.92. What is the ratio of the Gross enrolment ratio (%) in Zambia in 1979 to that in 1999?
Offer a very short reply. 1.08. What is the ratio of the Gross enrolment ratio (%) in East Asia (all income levels) in 1989 to that in 1990?
Your response must be concise. 1.02. What is the ratio of the Gross enrolment ratio (%) of Belarus in 1989 to that in 1990?
Your response must be concise. 1. What is the ratio of the Gross enrolment ratio (%) of Macao in 1989 to that in 1990?
Make the answer very short. 1.06. What is the ratio of the Gross enrolment ratio (%) of Zambia in 1989 to that in 1990?
Provide a succinct answer. 1.01. What is the ratio of the Gross enrolment ratio (%) in East Asia (all income levels) in 1989 to that in 1991?
Your answer should be very brief. 1.05. What is the ratio of the Gross enrolment ratio (%) of Belarus in 1989 to that in 1991?
Give a very brief answer. 0.98. What is the ratio of the Gross enrolment ratio (%) of Macao in 1989 to that in 1991?
Give a very brief answer. 1.07. What is the ratio of the Gross enrolment ratio (%) of Zambia in 1989 to that in 1991?
Give a very brief answer. 1. What is the ratio of the Gross enrolment ratio (%) in East Asia (all income levels) in 1989 to that in 1999?
Your answer should be very brief. 1.16. What is the ratio of the Gross enrolment ratio (%) in Belarus in 1989 to that in 1999?
Offer a very short reply. 0.85. What is the ratio of the Gross enrolment ratio (%) of Macao in 1989 to that in 1999?
Make the answer very short. 1.13. What is the ratio of the Gross enrolment ratio (%) of Zambia in 1989 to that in 1999?
Offer a terse response. 1.15. What is the ratio of the Gross enrolment ratio (%) of East Asia (all income levels) in 1990 to that in 1991?
Give a very brief answer. 1.03. What is the ratio of the Gross enrolment ratio (%) of Belarus in 1990 to that in 1991?
Make the answer very short. 0.98. What is the ratio of the Gross enrolment ratio (%) in Macao in 1990 to that in 1991?
Offer a terse response. 1.01. What is the ratio of the Gross enrolment ratio (%) of Zambia in 1990 to that in 1991?
Offer a very short reply. 0.99. What is the ratio of the Gross enrolment ratio (%) in East Asia (all income levels) in 1990 to that in 1999?
Your response must be concise. 1.14. What is the ratio of the Gross enrolment ratio (%) in Belarus in 1990 to that in 1999?
Keep it short and to the point. 0.85. What is the ratio of the Gross enrolment ratio (%) in Macao in 1990 to that in 1999?
Offer a terse response. 1.07. What is the ratio of the Gross enrolment ratio (%) in Zambia in 1990 to that in 1999?
Your answer should be compact. 1.14. What is the ratio of the Gross enrolment ratio (%) in East Asia (all income levels) in 1991 to that in 1999?
Offer a very short reply. 1.11. What is the ratio of the Gross enrolment ratio (%) of Belarus in 1991 to that in 1999?
Your response must be concise. 0.87. What is the ratio of the Gross enrolment ratio (%) of Macao in 1991 to that in 1999?
Your response must be concise. 1.05. What is the ratio of the Gross enrolment ratio (%) of Zambia in 1991 to that in 1999?
Keep it short and to the point. 1.15. What is the difference between the highest and the second highest Gross enrolment ratio (%) in East Asia (all income levels)?
Provide a short and direct response. 2.35. What is the difference between the highest and the second highest Gross enrolment ratio (%) of Belarus?
Make the answer very short. 8.97. What is the difference between the highest and the second highest Gross enrolment ratio (%) in Macao?
Your answer should be very brief. 5.9. What is the difference between the highest and the second highest Gross enrolment ratio (%) in Zambia?
Offer a terse response. 0.44. What is the difference between the highest and the lowest Gross enrolment ratio (%) of East Asia (all income levels)?
Your response must be concise. 16.8. What is the difference between the highest and the lowest Gross enrolment ratio (%) of Belarus?
Provide a short and direct response. 15.94. What is the difference between the highest and the lowest Gross enrolment ratio (%) of Macao?
Offer a terse response. 21.51. What is the difference between the highest and the lowest Gross enrolment ratio (%) in Zambia?
Your answer should be very brief. 12.92. 